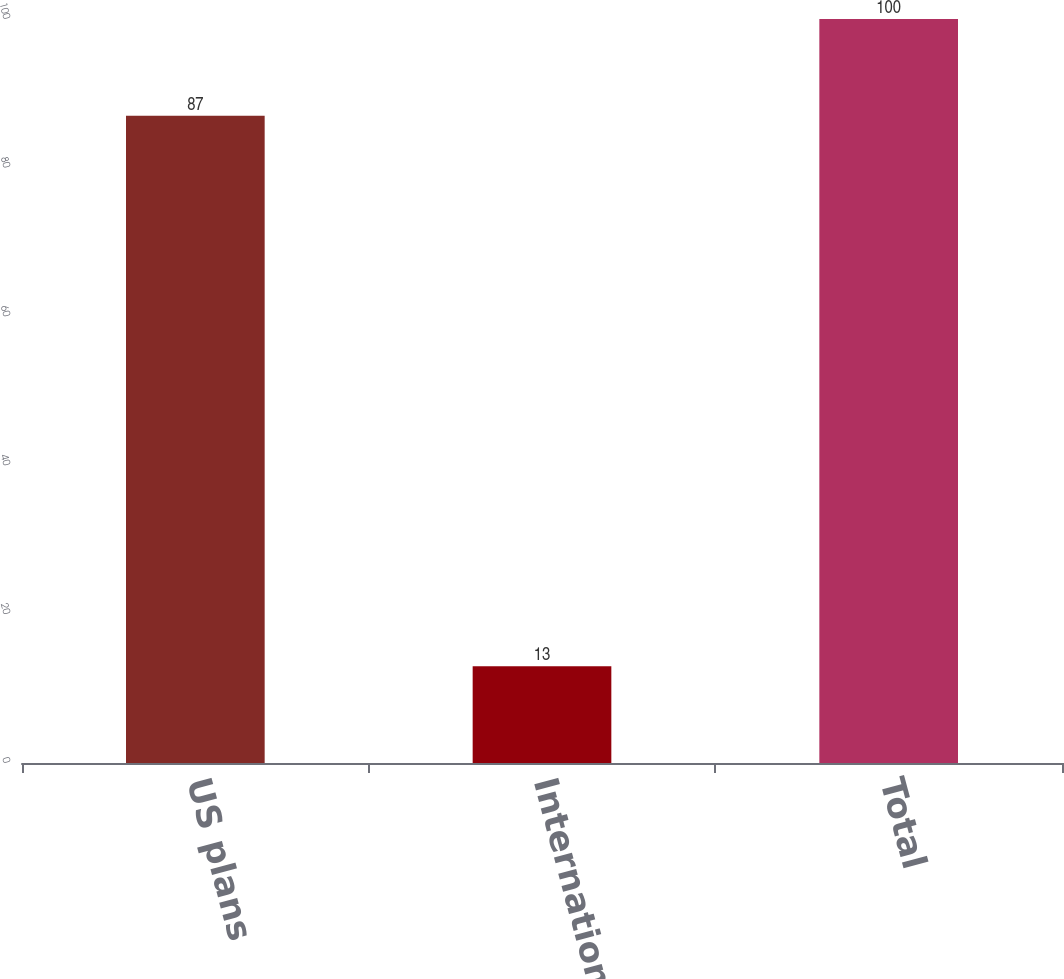<chart> <loc_0><loc_0><loc_500><loc_500><bar_chart><fcel>US plans<fcel>International plans<fcel>Total<nl><fcel>87<fcel>13<fcel>100<nl></chart> 